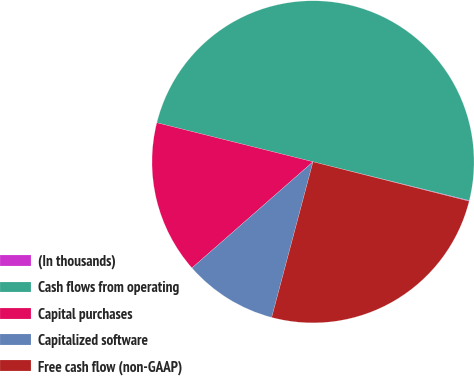Convert chart to OTSL. <chart><loc_0><loc_0><loc_500><loc_500><pie_chart><fcel>(In thousands)<fcel>Cash flows from operating<fcel>Capital purchases<fcel>Capitalized software<fcel>Free cash flow (non-GAAP)<nl><fcel>0.07%<fcel>49.97%<fcel>15.36%<fcel>9.41%<fcel>25.2%<nl></chart> 